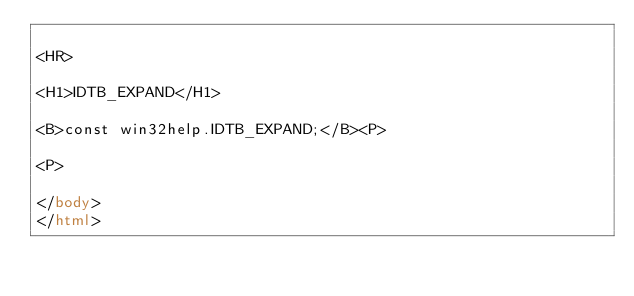Convert code to text. <code><loc_0><loc_0><loc_500><loc_500><_HTML_>
<HR>

<H1>IDTB_EXPAND</H1>

<B>const win32help.IDTB_EXPAND;</B><P>

<P>

</body>
</html></code> 